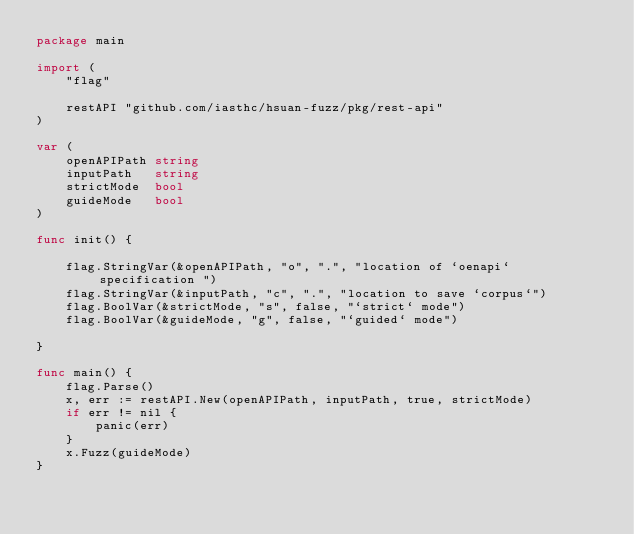Convert code to text. <code><loc_0><loc_0><loc_500><loc_500><_Go_>package main

import (
	"flag"

	restAPI "github.com/iasthc/hsuan-fuzz/pkg/rest-api"
)

var (
	openAPIPath string
	inputPath   string
	strictMode  bool
	guideMode   bool
)

func init() {

	flag.StringVar(&openAPIPath, "o", ".", "location of `oenapi` specification ")
	flag.StringVar(&inputPath, "c", ".", "location to save `corpus`")
	flag.BoolVar(&strictMode, "s", false, "`strict` mode")
	flag.BoolVar(&guideMode, "g", false, "`guided` mode")

}

func main() {
	flag.Parse()
	x, err := restAPI.New(openAPIPath, inputPath, true, strictMode)
	if err != nil {
		panic(err)
	}
	x.Fuzz(guideMode)
}
</code> 